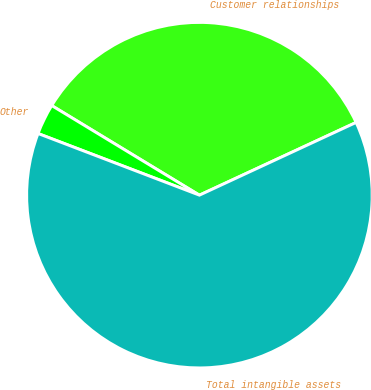Convert chart to OTSL. <chart><loc_0><loc_0><loc_500><loc_500><pie_chart><fcel>Customer relationships<fcel>Other<fcel>Total intangible assets<nl><fcel>34.41%<fcel>2.87%<fcel>62.73%<nl></chart> 